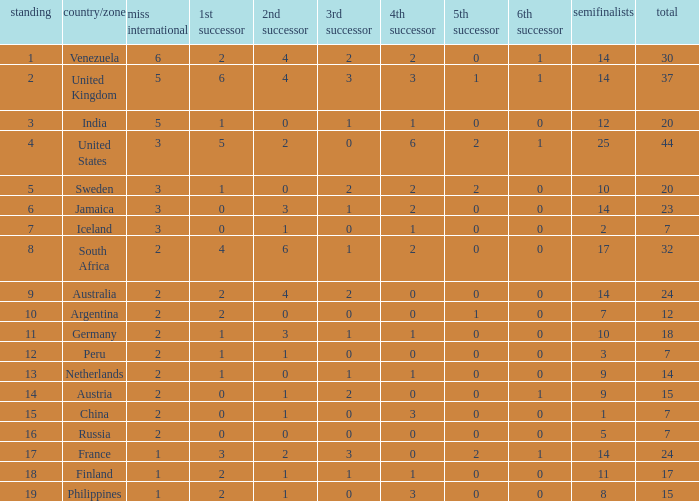What is Iceland's total? 1.0. 